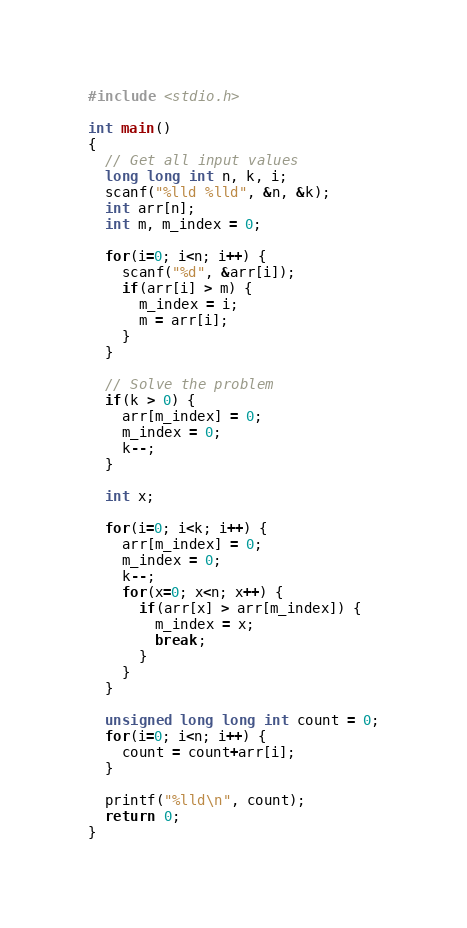Convert code to text. <code><loc_0><loc_0><loc_500><loc_500><_C_>#include <stdio.h>

int main()
{
  // Get all input values
  long long int n, k, i;
  scanf("%lld %lld", &n, &k);
  int arr[n];
  int m, m_index = 0;

  for(i=0; i<n; i++) {
    scanf("%d", &arr[i]);
    if(arr[i] > m) {
      m_index = i;
      m = arr[i];
    }
  }

  // Solve the problem
  if(k > 0) {
    arr[m_index] = 0;
    m_index = 0;
    k--;
  }

  int x;

  for(i=0; i<k; i++) {
    arr[m_index] = 0;
    m_index = 0;
    k--;
    for(x=0; x<n; x++) {
      if(arr[x] > arr[m_index]) {
        m_index = x;
        break;
      }
    }
  }

  unsigned long long int count = 0;
  for(i=0; i<n; i++) {
    count = count+arr[i];
  }

  printf("%lld\n", count);
  return 0;
}
</code> 